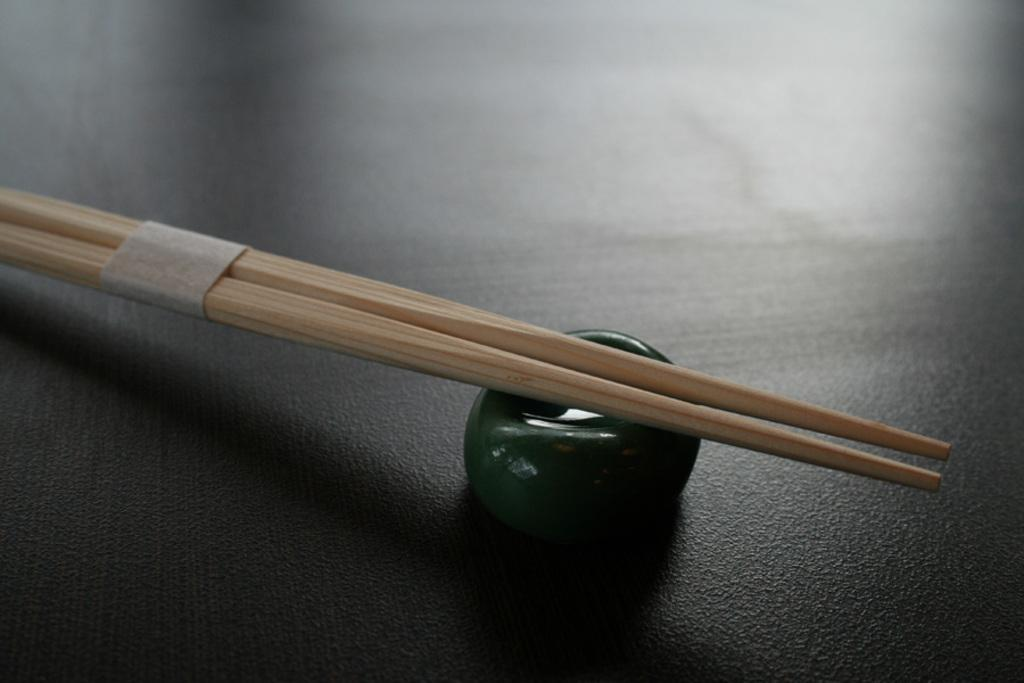What type of utensils are in the image? There are two wooden chopsticks in the image. How are the chopsticks arranged or held together? The chopsticks are tied up with a small piece of paper. What other object can be seen in the image? There is a small stone in the image. What is the color of the stone? The stone is green in color. Are the chopsticks and stone involved in a fight in the image? No, there is no fight depicted in the image; it only shows the chopsticks tied up with a piece of paper and a green stone. Can you tell me how many bags of popcorn are present in the image? There are no bags of popcorn present in the image. 